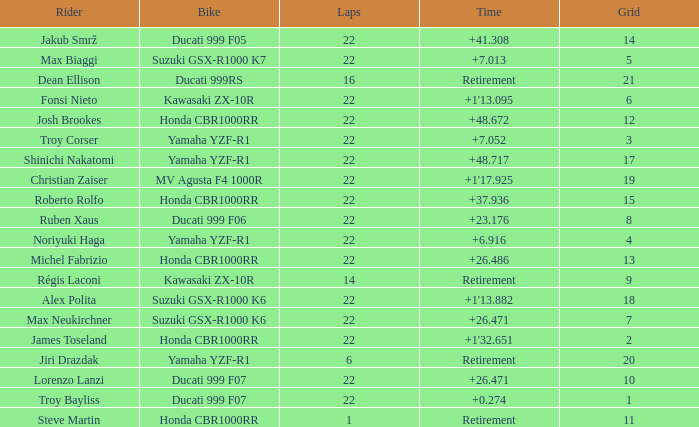Which bike did Jiri Drazdak ride when he had a grid number larger than 14 and less than 22 laps? Yamaha YZF-R1. 